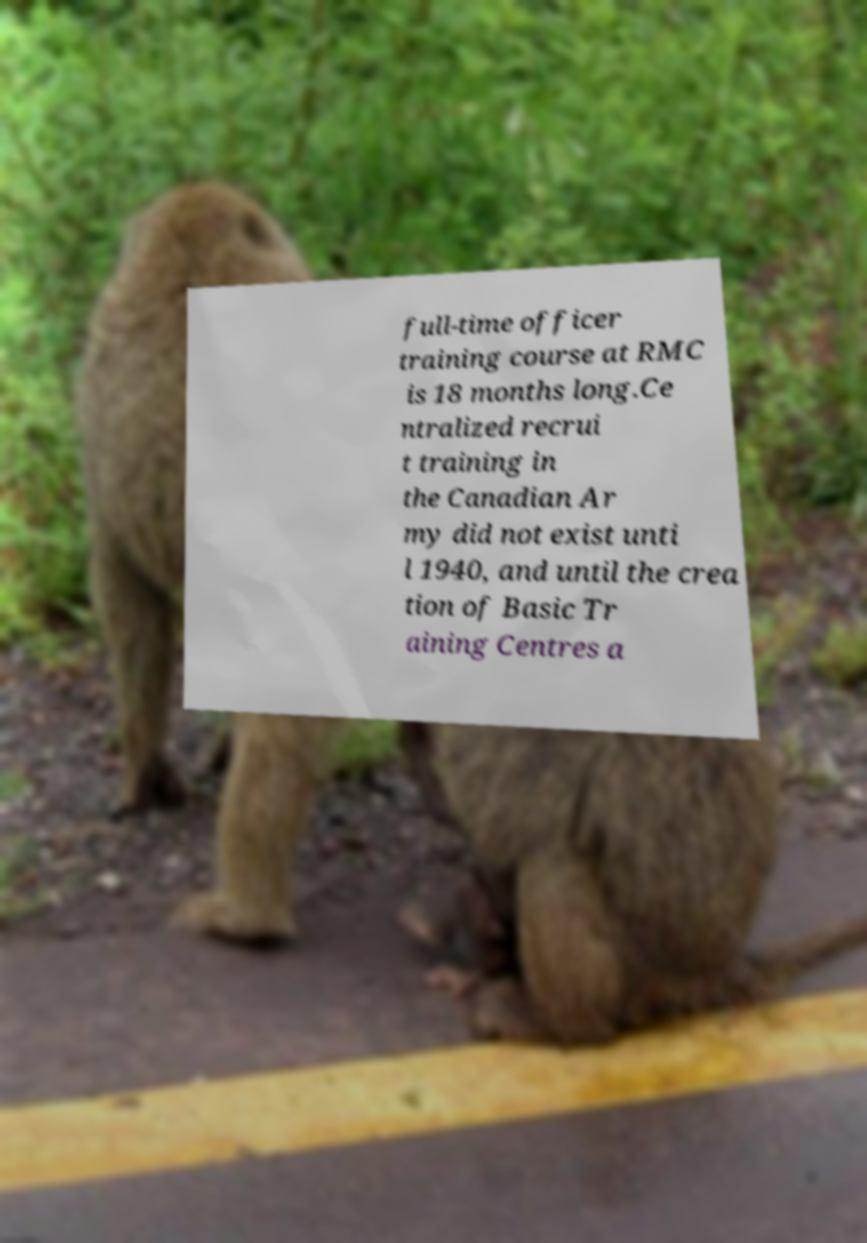I need the written content from this picture converted into text. Can you do that? full-time officer training course at RMC is 18 months long.Ce ntralized recrui t training in the Canadian Ar my did not exist unti l 1940, and until the crea tion of Basic Tr aining Centres a 